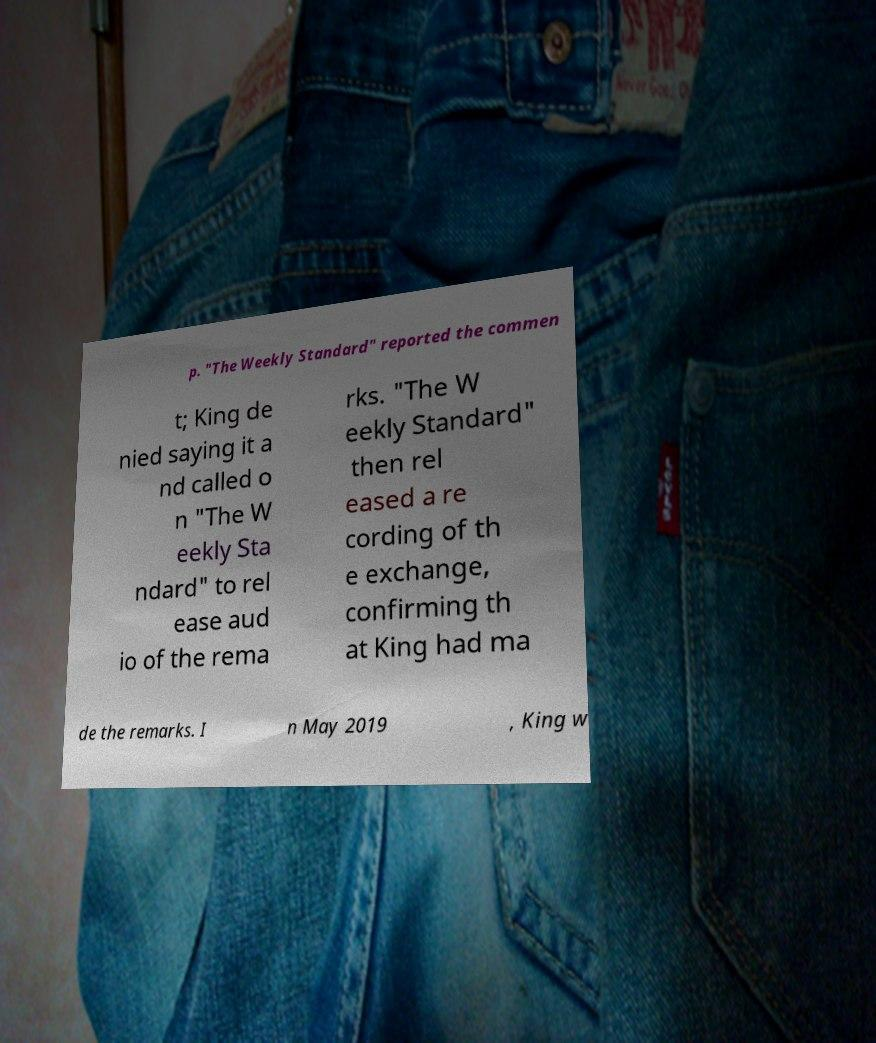There's text embedded in this image that I need extracted. Can you transcribe it verbatim? p. "The Weekly Standard" reported the commen t; King de nied saying it a nd called o n "The W eekly Sta ndard" to rel ease aud io of the rema rks. "The W eekly Standard" then rel eased a re cording of th e exchange, confirming th at King had ma de the remarks. I n May 2019 , King w 